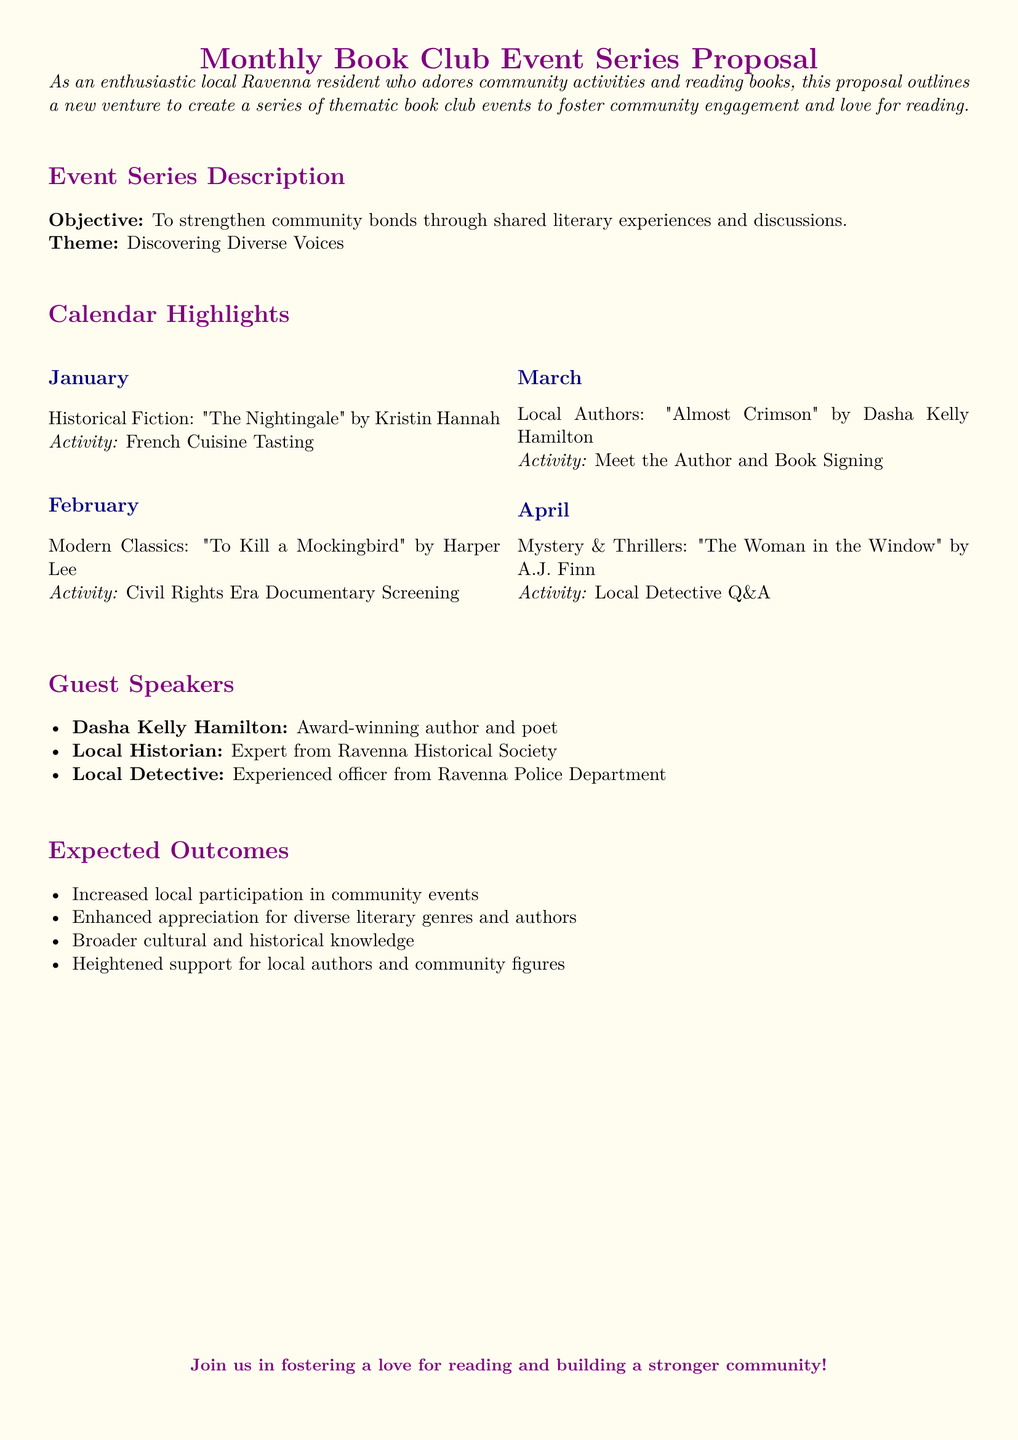What is the theme of the book club series? The theme is stated as "Discovering Diverse Voices" in the document.
Answer: Discovering Diverse Voices How many guest speakers are mentioned? The document lists three guest speakers who will participate in the events.
Answer: 3 What book is featured in February? The title of the book for February is given in the document along with its author.
Answer: To Kill a Mockingbird What activity is associated with the January meeting? The document specifies an activity related to the theme of the January meeting.
Answer: French Cuisine Tasting Who is the author of "Almost Crimson"? The document highlights the author of this specific book as a local author.
Answer: Dasha Kelly Hamilton What is one expected outcome of these events? The document lists multiple expected outcomes related to community engagement.
Answer: Increased local participation in community events What type of literature is explored in March? The document provides genres for each month's book selection.
Answer: Local Authors Which organization is mentioned alongside the local historian? The document identifies the local historian's association with a specific local group.
Answer: Ravenna Historical Society 